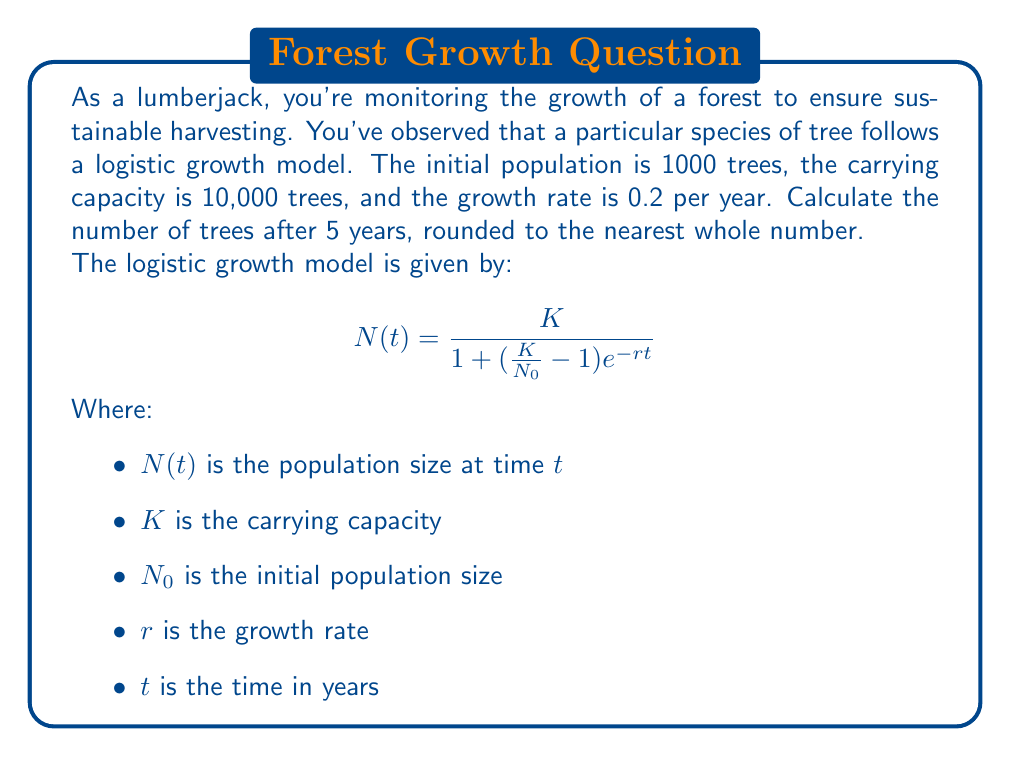Could you help me with this problem? To solve this problem, we'll use the logistic growth model equation and plug in the given values:

$K = 10,000$ (carrying capacity)
$N_0 = 1,000$ (initial population)
$r = 0.2$ (growth rate)
$t = 5$ (time in years)

Let's substitute these values into the equation:

$$N(5) = \frac{10,000}{1 + (\frac{10,000}{1,000} - 1)e^{-0.2 \cdot 5}}$$

Now, let's solve this step-by-step:

1) First, simplify the fraction inside the parentheses:
   $$N(5) = \frac{10,000}{1 + (10 - 1)e^{-1}}$$

2) Simplify further:
   $$N(5) = \frac{10,000}{1 + 9e^{-1}}$$

3) Calculate $e^{-1}$:
   $e^{-1} \approx 0.3679$

4) Multiply:
   $$N(5) = \frac{10,000}{1 + 9 \cdot 0.3679} = \frac{10,000}{1 + 3.3111}$$

5) Add in the denominator:
   $$N(5) = \frac{10,000}{4.3111}$$

6) Divide:
   $$N(5) \approx 2,319.8$$

7) Round to the nearest whole number:
   $$N(5) \approx 2,320$$

Therefore, after 5 years, there will be approximately 2,320 trees.
Answer: 2,320 trees 